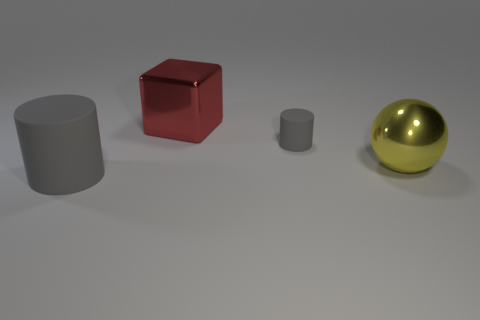Add 2 large blue matte spheres. How many objects exist? 6 Subtract all blocks. How many objects are left? 3 Add 4 rubber cylinders. How many rubber cylinders are left? 6 Add 4 large metallic things. How many large metallic things exist? 6 Subtract 0 green balls. How many objects are left? 4 Subtract all red blocks. Subtract all large brown matte spheres. How many objects are left? 3 